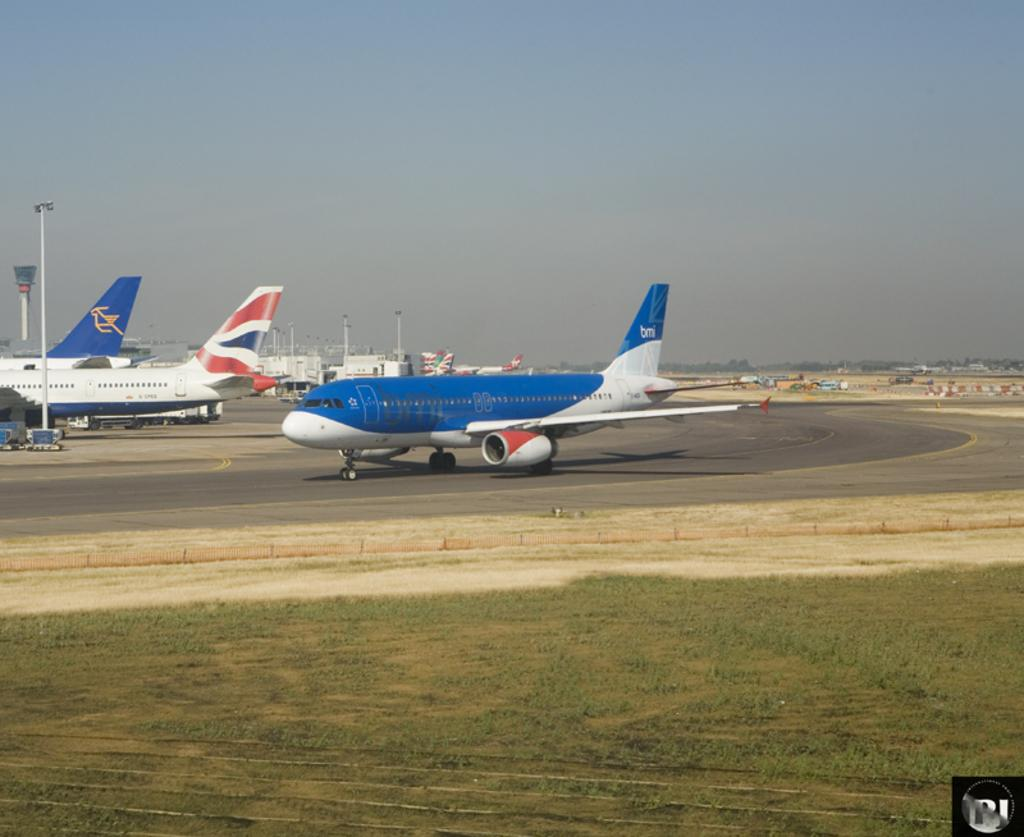What type of vehicles are on the road in the image? There are aeroplanes on the road in the image. What type of structures can be seen in the image? There are sheds in the image. What is visible at the bottom of the image? The ground is visible at the bottom of the image. What type of vacation is being advertised on the sheds in the image? There is no indication of a vacation being advertised on the sheds in the image. What type of sticks are being used to build the sheds in the image? There are no sticks visible in the image; the sheds appear to be made of other materials. 